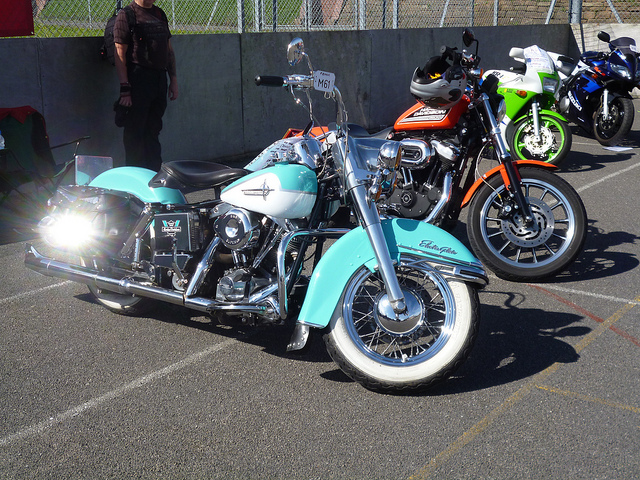Identify the text displayed in this image. M61 